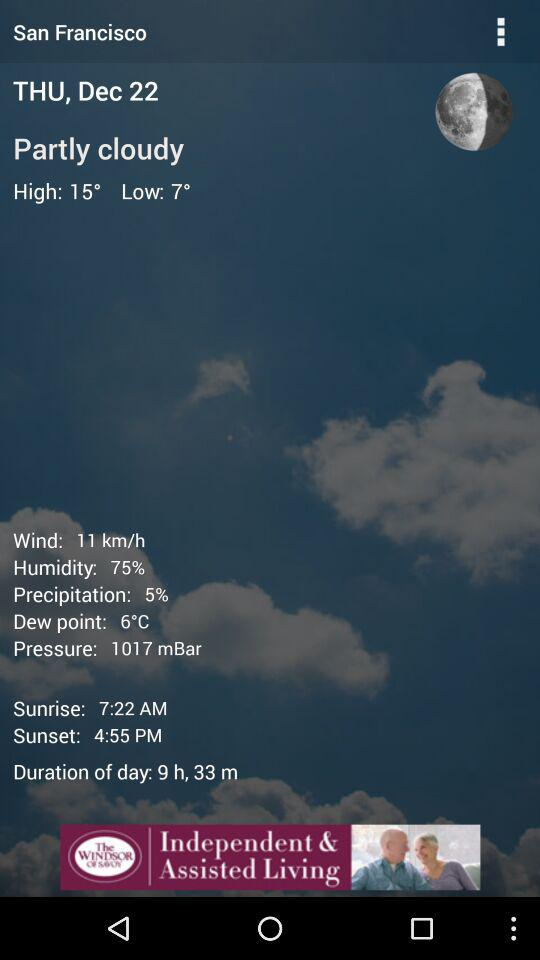Which day falls on December 22? The day is Thursday. 